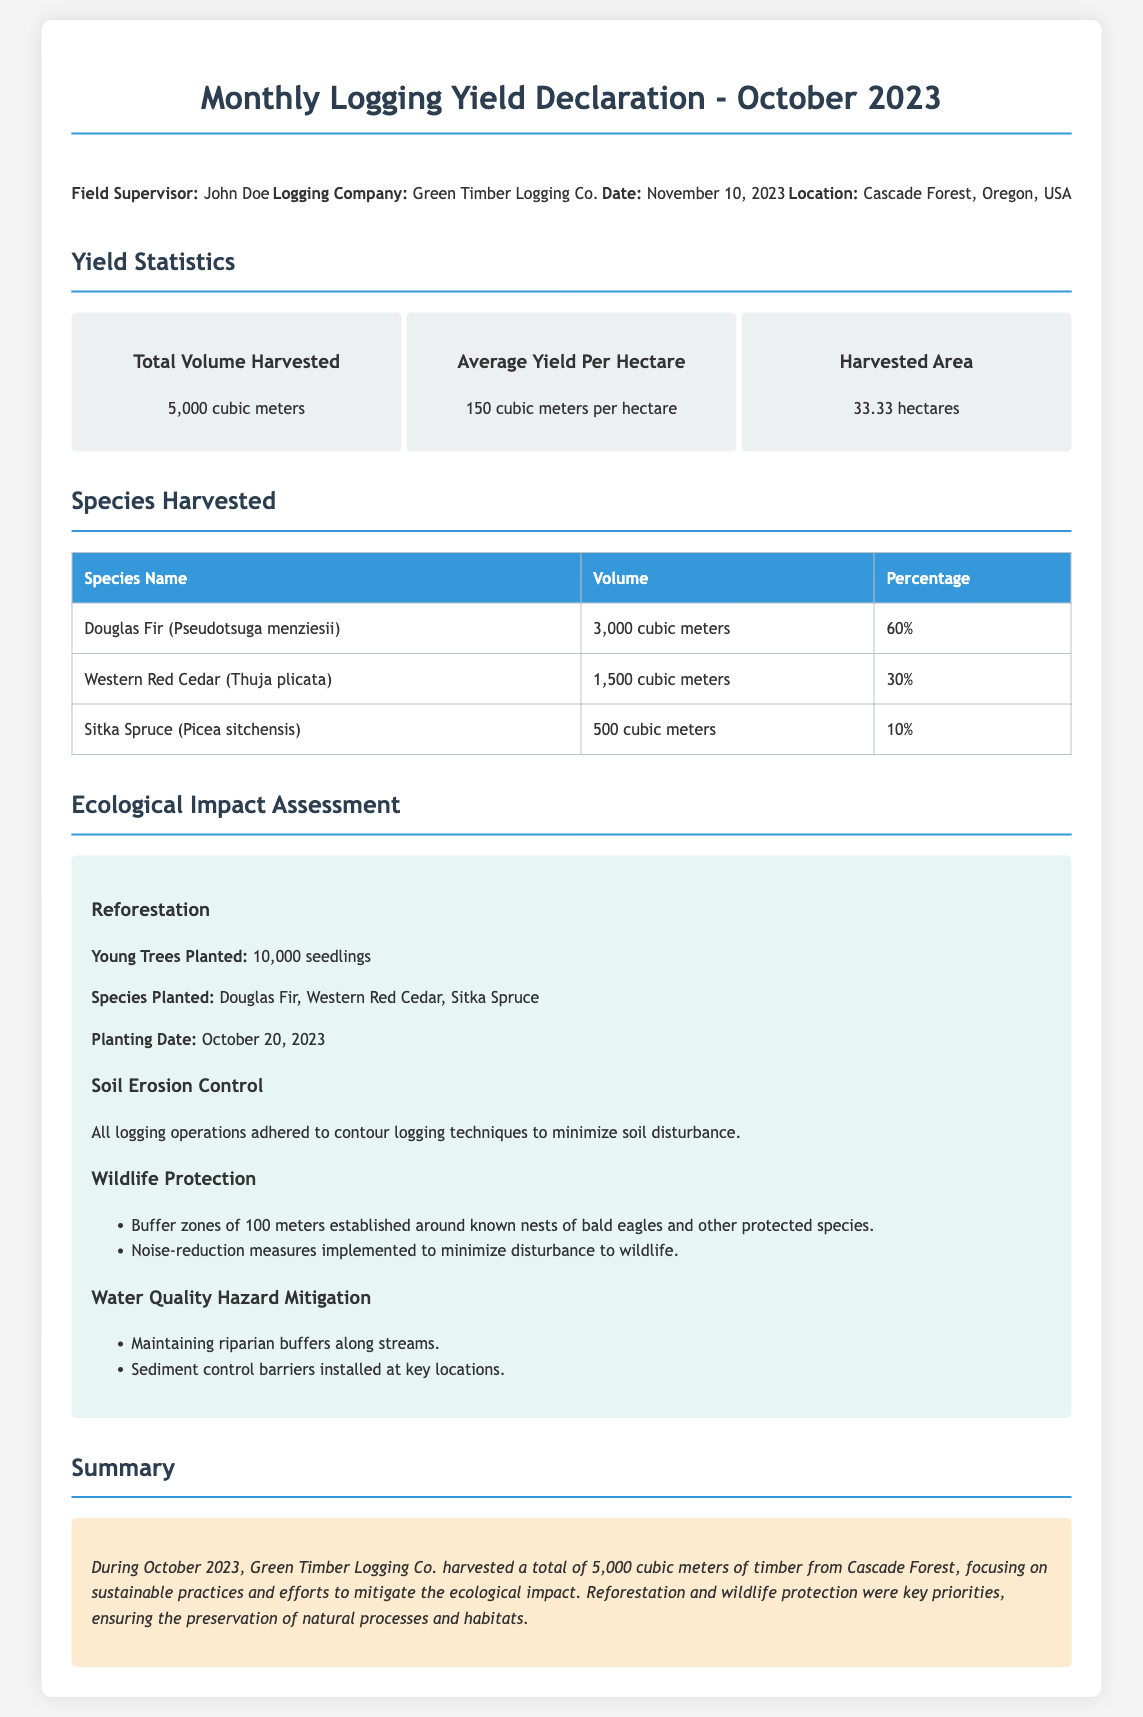What is the total volume harvested? The total volume harvested is provided in the yield statistics section of the document.
Answer: 5,000 cubic meters What is the average yield per hectare? The average yield per hectare is mentioned in the yield statistics section of the document.
Answer: 150 cubic meters per hectare What species contributed 60% of the harvested volume? The species that contributed 60% is specified in the species harvested section.
Answer: Douglas Fir (Pseudotsuga menziesii) How many seedlings were planted for reforestation? The number of seedlings planted is detailed in the ecological impact assessment section.
Answer: 10,000 seedlings What area was logged in hectares? The area logged is mentioned in the yield statistics section of the document.
Answer: 33.33 hectares What measures were taken for wildlife protection? The wildlife protection measures are listed in the ecological impact assessment section of the document.
Answer: Buffer zones, noise-reduction measures When was the planting date for the seedlings? The planting date is provided in the ecological impact assessment under reforestation.
Answer: October 20, 2023 Which logging company is responsible for the operations? The logging company is stated in the company info section of the document.
Answer: Green Timber Logging Co What is the location of the logging operations? The location is specified in the company info section of the document.
Answer: Cascade Forest, Oregon, USA 